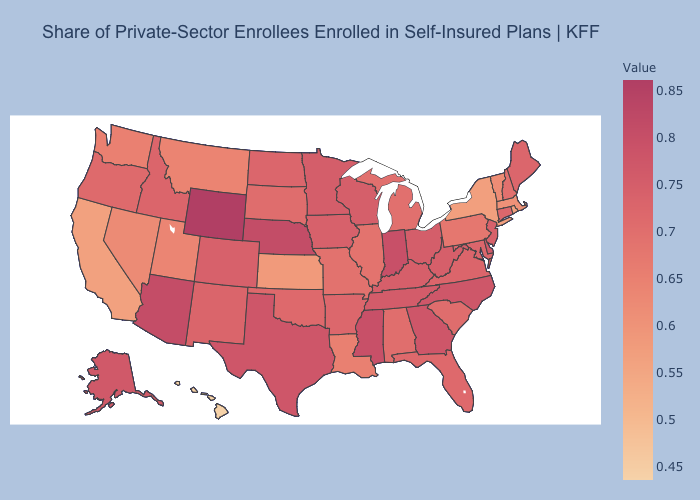Does Alaska have a lower value than Wyoming?
Be succinct. Yes. Does Alaska have the highest value in the West?
Short answer required. No. Which states have the lowest value in the MidWest?
Quick response, please. Kansas. Among the states that border Arkansas , does Mississippi have the highest value?
Quick response, please. Yes. Does Kansas have the lowest value in the MidWest?
Write a very short answer. Yes. Does the map have missing data?
Give a very brief answer. No. 